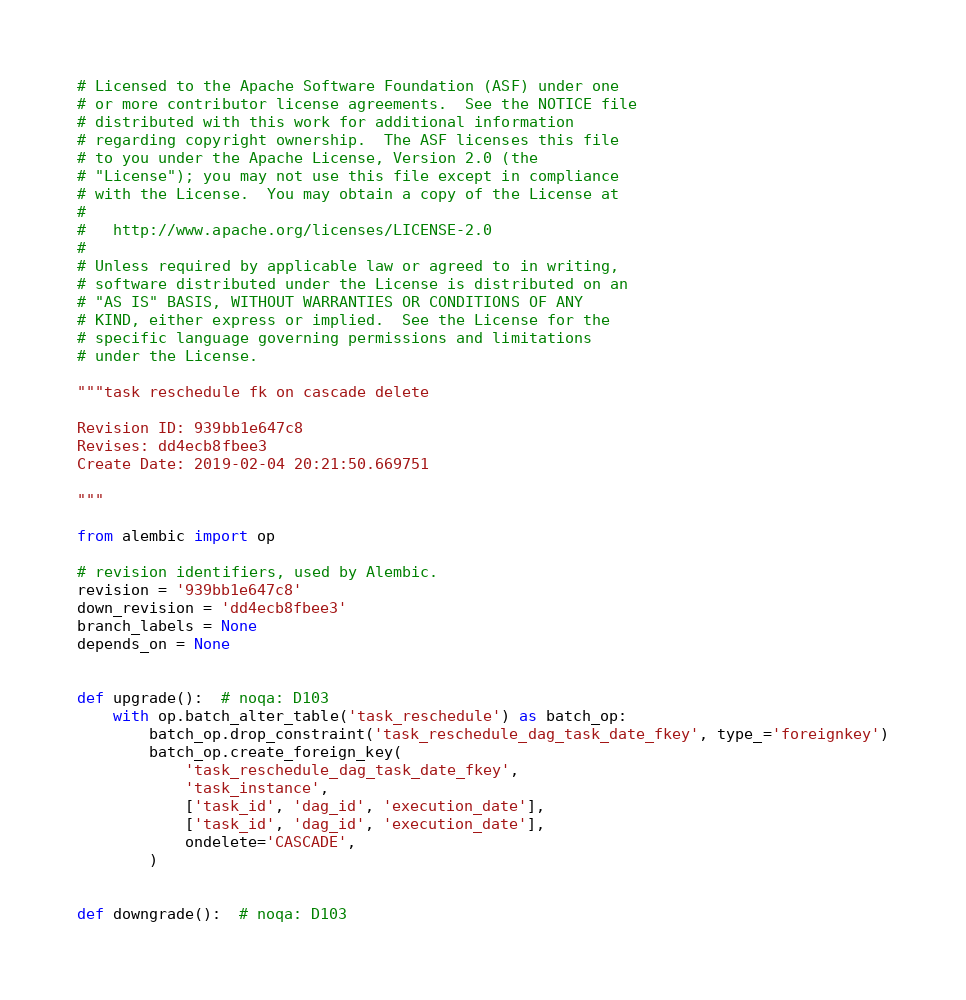<code> <loc_0><loc_0><loc_500><loc_500><_Python_># Licensed to the Apache Software Foundation (ASF) under one
# or more contributor license agreements.  See the NOTICE file
# distributed with this work for additional information
# regarding copyright ownership.  The ASF licenses this file
# to you under the Apache License, Version 2.0 (the
# "License"); you may not use this file except in compliance
# with the License.  You may obtain a copy of the License at
#
#   http://www.apache.org/licenses/LICENSE-2.0
#
# Unless required by applicable law or agreed to in writing,
# software distributed under the License is distributed on an
# "AS IS" BASIS, WITHOUT WARRANTIES OR CONDITIONS OF ANY
# KIND, either express or implied.  See the License for the
# specific language governing permissions and limitations
# under the License.

"""task reschedule fk on cascade delete

Revision ID: 939bb1e647c8
Revises: dd4ecb8fbee3
Create Date: 2019-02-04 20:21:50.669751

"""

from alembic import op

# revision identifiers, used by Alembic.
revision = '939bb1e647c8'
down_revision = 'dd4ecb8fbee3'
branch_labels = None
depends_on = None


def upgrade():  # noqa: D103
    with op.batch_alter_table('task_reschedule') as batch_op:
        batch_op.drop_constraint('task_reschedule_dag_task_date_fkey', type_='foreignkey')
        batch_op.create_foreign_key(
            'task_reschedule_dag_task_date_fkey',
            'task_instance',
            ['task_id', 'dag_id', 'execution_date'],
            ['task_id', 'dag_id', 'execution_date'],
            ondelete='CASCADE',
        )


def downgrade():  # noqa: D103</code> 